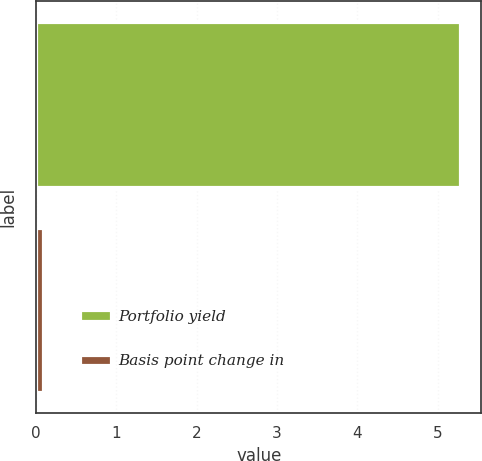<chart> <loc_0><loc_0><loc_500><loc_500><bar_chart><fcel>Portfolio yield<fcel>Basis point change in<nl><fcel>5.28<fcel>0.08<nl></chart> 